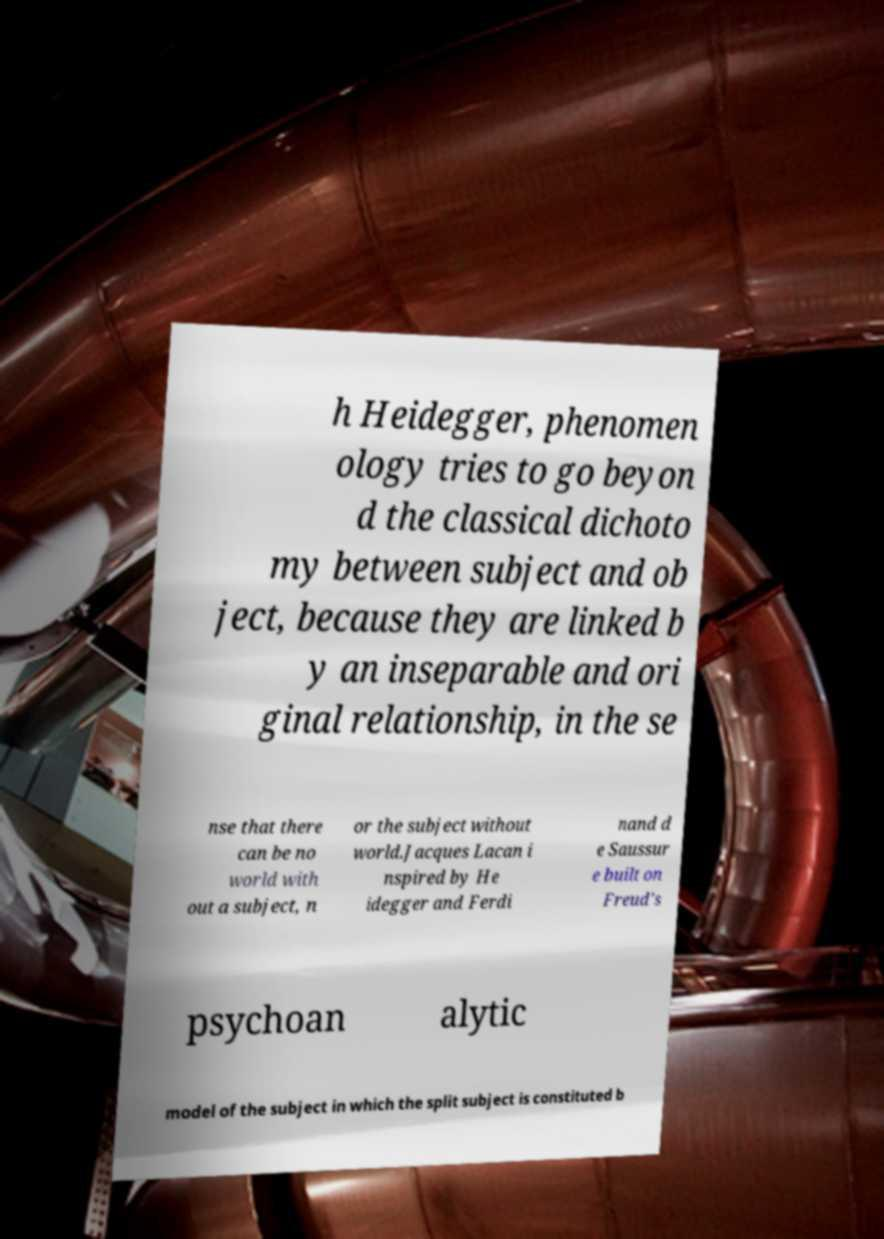Please identify and transcribe the text found in this image. h Heidegger, phenomen ology tries to go beyon d the classical dichoto my between subject and ob ject, because they are linked b y an inseparable and ori ginal relationship, in the se nse that there can be no world with out a subject, n or the subject without world.Jacques Lacan i nspired by He idegger and Ferdi nand d e Saussur e built on Freud's psychoan alytic model of the subject in which the split subject is constituted b 